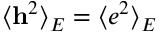<formula> <loc_0><loc_0><loc_500><loc_500>\langle \mathbf h ^ { 2 } \rangle _ { E } = \langle e ^ { 2 } \rangle _ { E }</formula> 